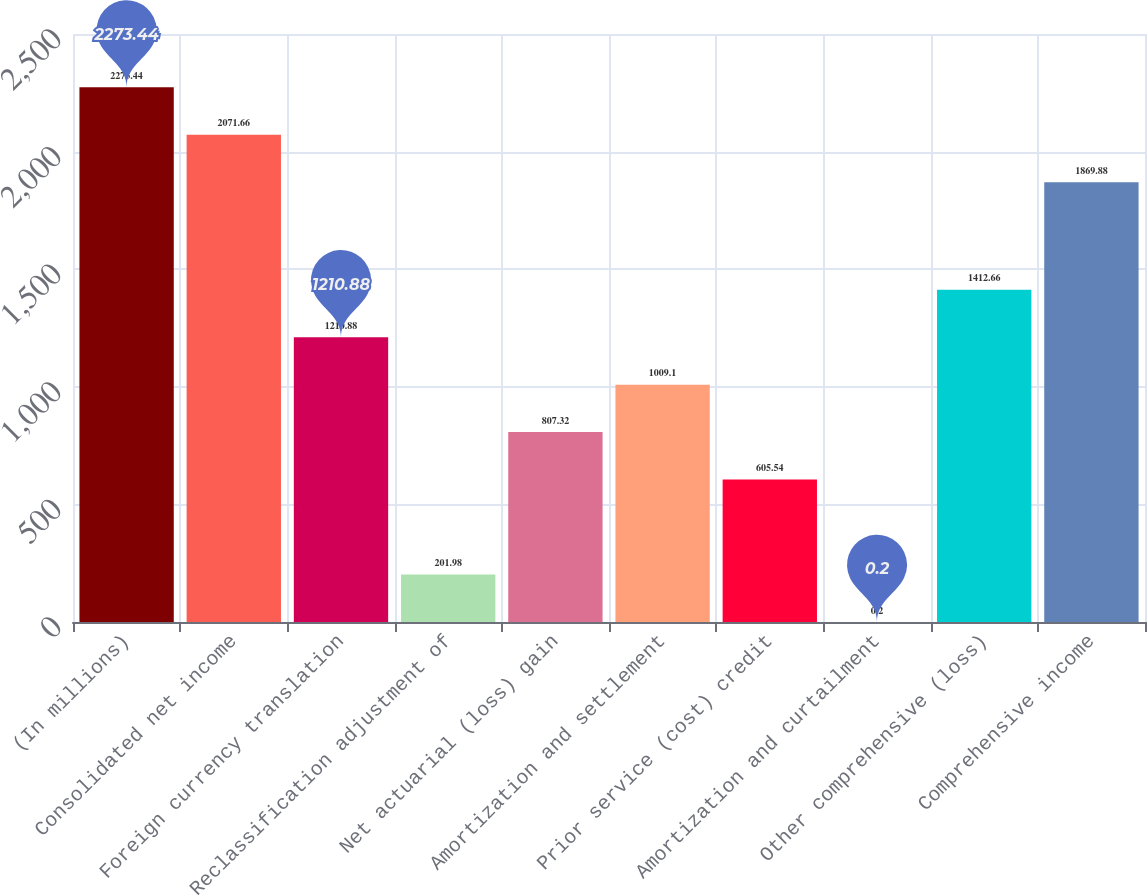Convert chart to OTSL. <chart><loc_0><loc_0><loc_500><loc_500><bar_chart><fcel>(In millions)<fcel>Consolidated net income<fcel>Foreign currency translation<fcel>Reclassification adjustment of<fcel>Net actuarial (loss) gain<fcel>Amortization and settlement<fcel>Prior service (cost) credit<fcel>Amortization and curtailment<fcel>Other comprehensive (loss)<fcel>Comprehensive income<nl><fcel>2273.44<fcel>2071.66<fcel>1210.88<fcel>201.98<fcel>807.32<fcel>1009.1<fcel>605.54<fcel>0.2<fcel>1412.66<fcel>1869.88<nl></chart> 